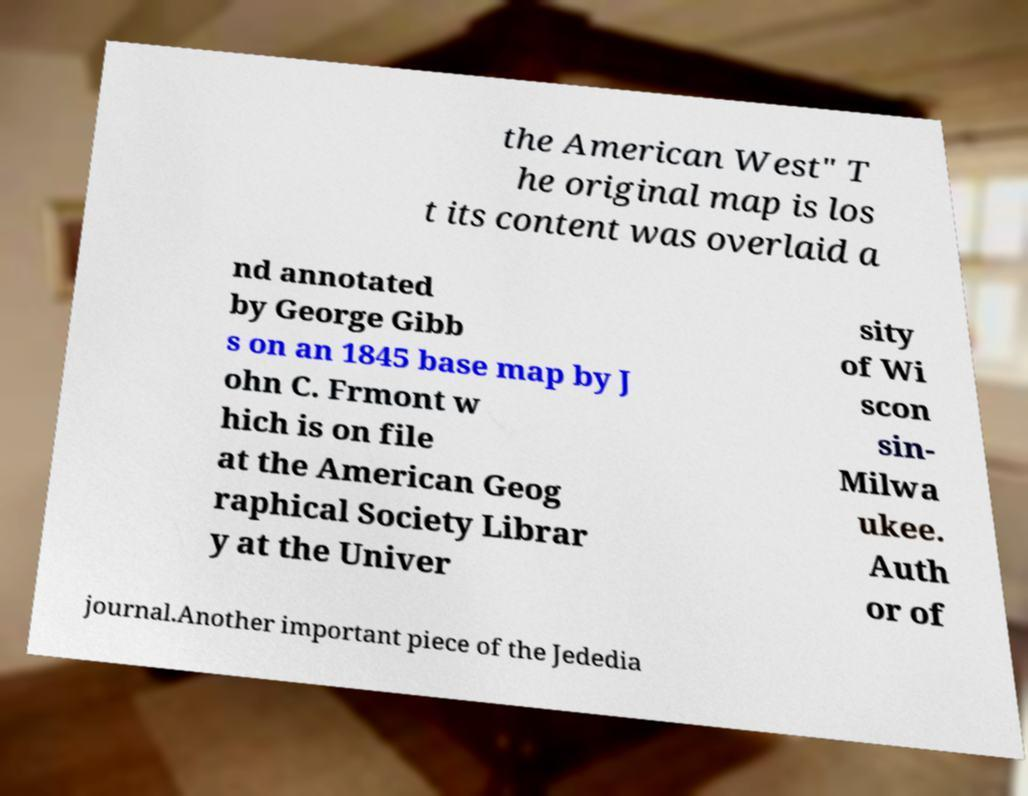What messages or text are displayed in this image? I need them in a readable, typed format. the American West" T he original map is los t its content was overlaid a nd annotated by George Gibb s on an 1845 base map by J ohn C. Frmont w hich is on file at the American Geog raphical Society Librar y at the Univer sity of Wi scon sin- Milwa ukee. Auth or of journal.Another important piece of the Jededia 